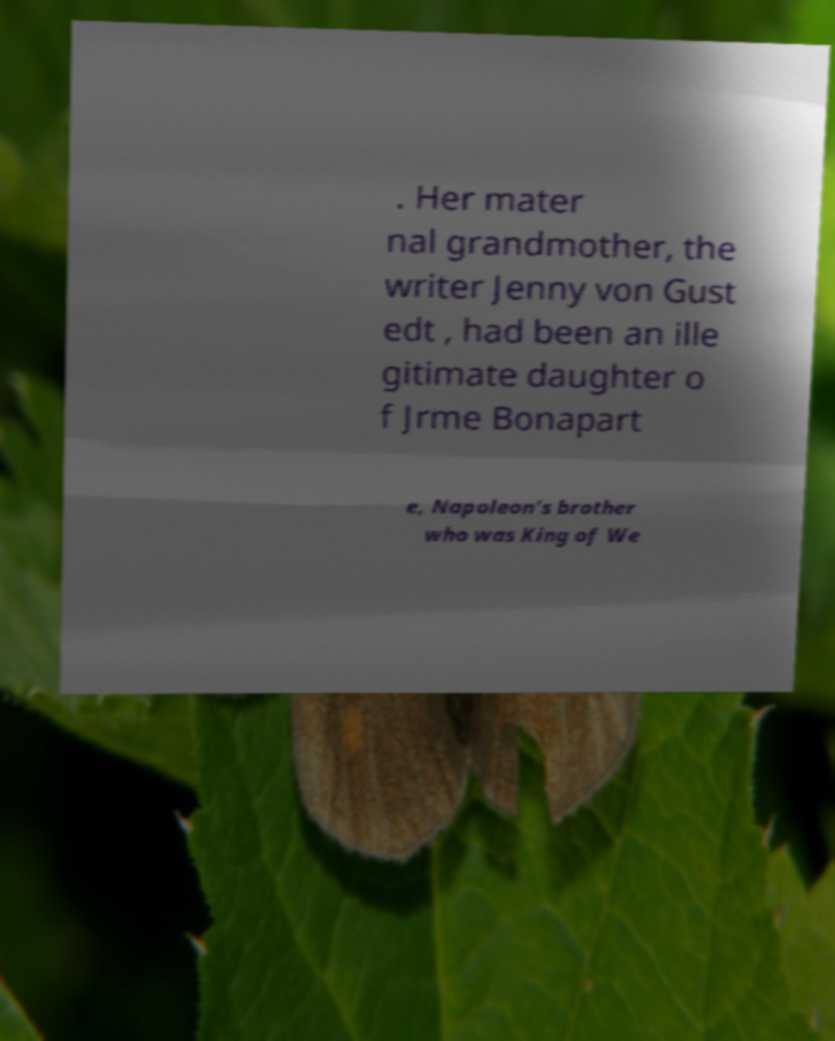What messages or text are displayed in this image? I need them in a readable, typed format. . Her mater nal grandmother, the writer Jenny von Gust edt , had been an ille gitimate daughter o f Jrme Bonapart e, Napoleon's brother who was King of We 